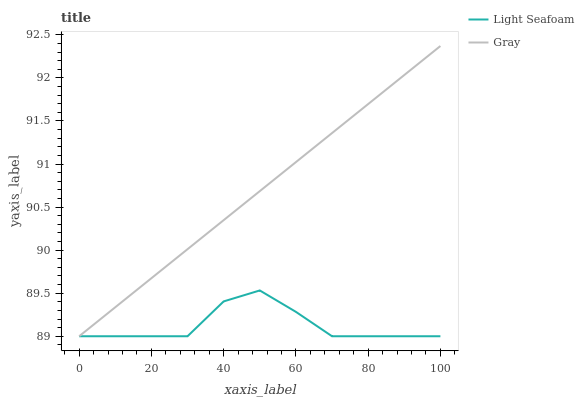Does Light Seafoam have the minimum area under the curve?
Answer yes or no. Yes. Does Gray have the maximum area under the curve?
Answer yes or no. Yes. Does Light Seafoam have the maximum area under the curve?
Answer yes or no. No. Is Gray the smoothest?
Answer yes or no. Yes. Is Light Seafoam the roughest?
Answer yes or no. Yes. Is Light Seafoam the smoothest?
Answer yes or no. No. Does Gray have the lowest value?
Answer yes or no. Yes. Does Gray have the highest value?
Answer yes or no. Yes. Does Light Seafoam have the highest value?
Answer yes or no. No. Does Gray intersect Light Seafoam?
Answer yes or no. Yes. Is Gray less than Light Seafoam?
Answer yes or no. No. Is Gray greater than Light Seafoam?
Answer yes or no. No. 